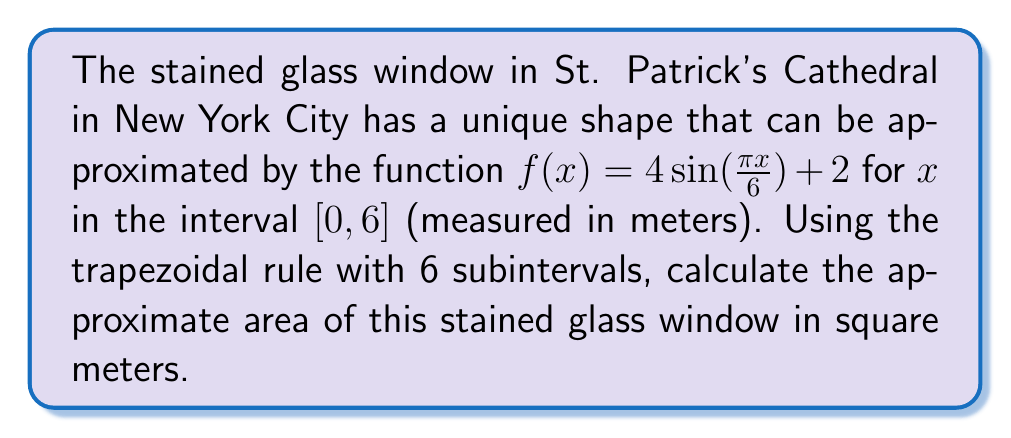Could you help me with this problem? To solve this problem, we'll use the trapezoidal rule for numerical integration. The trapezoidal rule approximates the area under a curve by dividing it into trapezoids.

1) The trapezoidal rule formula for n subintervals is:

   $$\int_{a}^{b} f(x) dx \approx \frac{b-a}{2n} [f(a) + 2f(x_1) + 2f(x_2) + ... + 2f(x_{n-1}) + f(b)]$$

2) In our case, $a=0$, $b=6$, and $n=6$. Let's calculate the step size:

   $$h = \frac{b-a}{n} = \frac{6-0}{6} = 1$$

3) Now, we need to evaluate $f(x)$ at $x = 0, 1, 2, 3, 4, 5, 6$:

   $f(0) = 4 \sin(0) + 2 = 2$
   $f(1) = 4 \sin(\frac{\pi}{6}) + 2 = 4$
   $f(2) = 4 \sin(\frac{\pi}{3}) + 2 = 5.464$
   $f(3) = 4 \sin(\frac{\pi}{2}) + 2 = 6$
   $f(4) = 4 \sin(\frac{2\pi}{3}) + 2 = 5.464$
   $f(5) = 4 \sin(\frac{5\pi}{6}) + 2 = 4$
   $f(6) = 4 \sin(\pi) + 2 = 2$

4) Applying the trapezoidal rule:

   $$\text{Area} \approx \frac{1}{2} [2 + 2(4 + 5.464 + 6 + 5.464 + 4) + 2]$$

5) Simplifying:

   $$\text{Area} \approx \frac{1}{2} [2 + 49.856 + 2] = \frac{53.856}{2} = 26.928$$

Therefore, the approximate area of the stained glass window is 26.928 square meters.
Answer: 26.928 square meters 